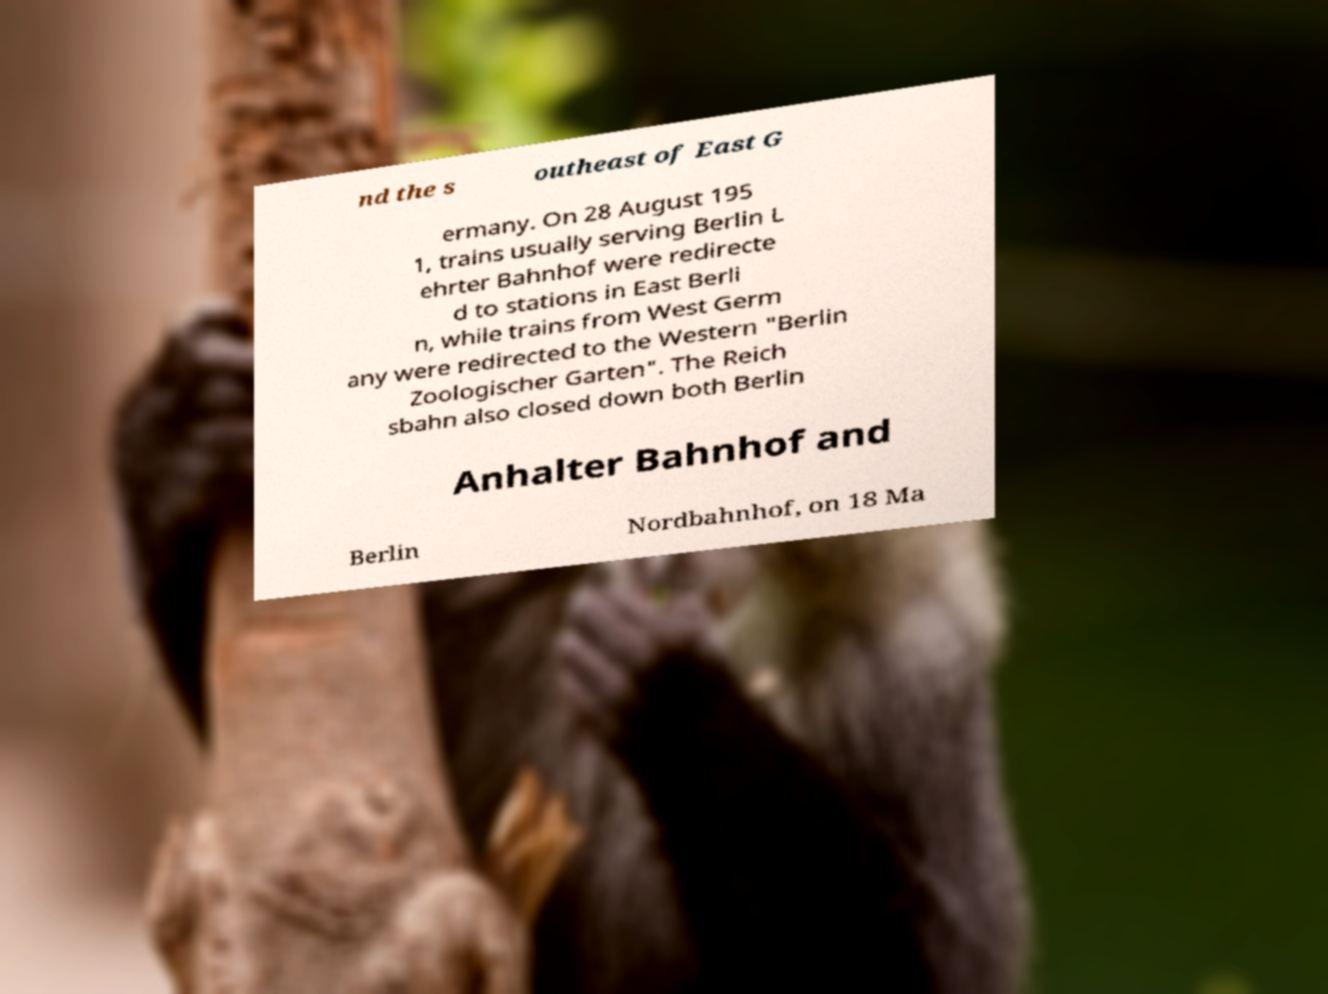Can you accurately transcribe the text from the provided image for me? nd the s outheast of East G ermany. On 28 August 195 1, trains usually serving Berlin L ehrter Bahnhof were redirecte d to stations in East Berli n, while trains from West Germ any were redirected to the Western "Berlin Zoologischer Garten". The Reich sbahn also closed down both Berlin Anhalter Bahnhof and Berlin Nordbahnhof, on 18 Ma 